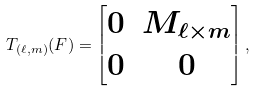Convert formula to latex. <formula><loc_0><loc_0><loc_500><loc_500>T _ { ( \ell , m ) } ( F ) = \begin{bmatrix} 0 & M _ { \ell \times m } \\ 0 & 0 \end{bmatrix} ,</formula> 